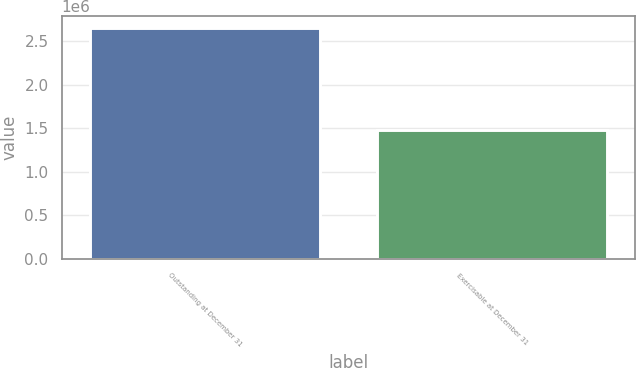Convert chart to OTSL. <chart><loc_0><loc_0><loc_500><loc_500><bar_chart><fcel>Outstanding at December 31<fcel>Exercisable at December 31<nl><fcel>2.6578e+06<fcel>1.47918e+06<nl></chart> 